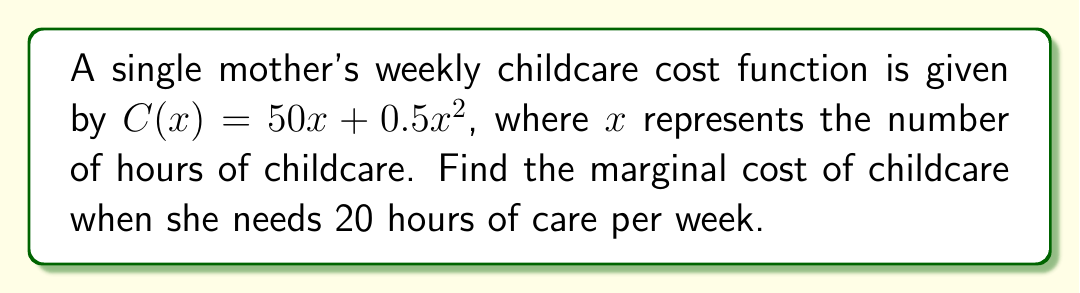What is the answer to this math problem? To find the marginal cost, we need to calculate the derivative of the cost function:

1) The cost function is $C(x) = 50x + 0.5x^2$

2) To find the derivative, we use the power rule and constant multiple rule:
   $$\frac{d}{dx}(50x) = 50$$
   $$\frac{d}{dx}(0.5x^2) = 0.5 \cdot 2x = x$$

3) Combining these results, we get the marginal cost function:
   $$C'(x) = 50 + x$$

4) To find the marginal cost at 20 hours, we substitute $x = 20$ into the marginal cost function:
   $$C'(20) = 50 + 20 = 70$$

Therefore, the marginal cost of childcare when the mother needs 20 hours of care per week is $70 per hour.
Answer: $70 per hour 